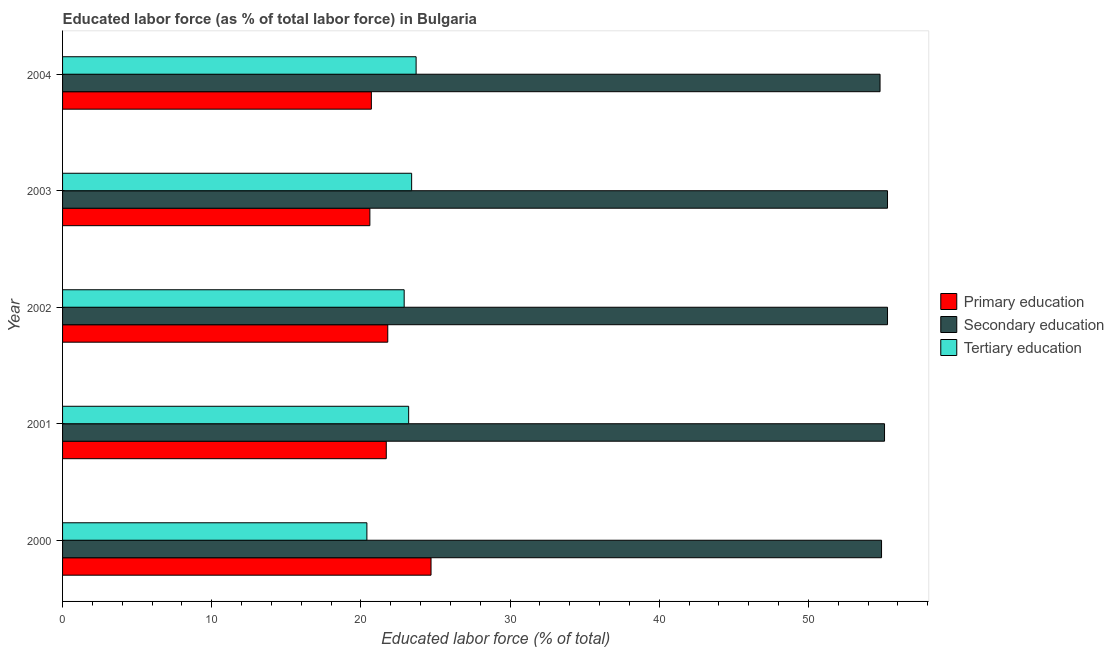Are the number of bars on each tick of the Y-axis equal?
Ensure brevity in your answer.  Yes. How many bars are there on the 5th tick from the bottom?
Provide a short and direct response. 3. What is the label of the 2nd group of bars from the top?
Keep it short and to the point. 2003. In how many cases, is the number of bars for a given year not equal to the number of legend labels?
Keep it short and to the point. 0. What is the percentage of labor force who received tertiary education in 2001?
Ensure brevity in your answer.  23.2. Across all years, what is the maximum percentage of labor force who received secondary education?
Offer a terse response. 55.3. Across all years, what is the minimum percentage of labor force who received tertiary education?
Provide a succinct answer. 20.4. In which year was the percentage of labor force who received primary education maximum?
Your answer should be very brief. 2000. In which year was the percentage of labor force who received secondary education minimum?
Offer a terse response. 2004. What is the total percentage of labor force who received secondary education in the graph?
Offer a very short reply. 275.4. What is the difference between the percentage of labor force who received tertiary education in 2002 and the percentage of labor force who received secondary education in 2000?
Provide a succinct answer. -32. What is the average percentage of labor force who received tertiary education per year?
Make the answer very short. 22.72. In the year 2002, what is the difference between the percentage of labor force who received secondary education and percentage of labor force who received tertiary education?
Offer a very short reply. 32.4. In how many years, is the percentage of labor force who received secondary education greater than 46 %?
Keep it short and to the point. 5. What is the difference between the highest and the second highest percentage of labor force who received secondary education?
Provide a short and direct response. 0. What is the difference between the highest and the lowest percentage of labor force who received secondary education?
Provide a succinct answer. 0.5. What does the 1st bar from the top in 2004 represents?
Give a very brief answer. Tertiary education. What does the 3rd bar from the bottom in 2003 represents?
Give a very brief answer. Tertiary education. Is it the case that in every year, the sum of the percentage of labor force who received primary education and percentage of labor force who received secondary education is greater than the percentage of labor force who received tertiary education?
Offer a very short reply. Yes. What is the difference between two consecutive major ticks on the X-axis?
Your answer should be compact. 10. Does the graph contain any zero values?
Give a very brief answer. No. Where does the legend appear in the graph?
Ensure brevity in your answer.  Center right. What is the title of the graph?
Give a very brief answer. Educated labor force (as % of total labor force) in Bulgaria. Does "Labor Tax" appear as one of the legend labels in the graph?
Provide a succinct answer. No. What is the label or title of the X-axis?
Your answer should be compact. Educated labor force (% of total). What is the label or title of the Y-axis?
Your answer should be very brief. Year. What is the Educated labor force (% of total) of Primary education in 2000?
Your answer should be compact. 24.7. What is the Educated labor force (% of total) of Secondary education in 2000?
Provide a succinct answer. 54.9. What is the Educated labor force (% of total) of Tertiary education in 2000?
Your answer should be very brief. 20.4. What is the Educated labor force (% of total) of Primary education in 2001?
Provide a succinct answer. 21.7. What is the Educated labor force (% of total) of Secondary education in 2001?
Give a very brief answer. 55.1. What is the Educated labor force (% of total) of Tertiary education in 2001?
Provide a succinct answer. 23.2. What is the Educated labor force (% of total) in Primary education in 2002?
Keep it short and to the point. 21.8. What is the Educated labor force (% of total) in Secondary education in 2002?
Give a very brief answer. 55.3. What is the Educated labor force (% of total) of Tertiary education in 2002?
Make the answer very short. 22.9. What is the Educated labor force (% of total) in Primary education in 2003?
Provide a succinct answer. 20.6. What is the Educated labor force (% of total) of Secondary education in 2003?
Your answer should be very brief. 55.3. What is the Educated labor force (% of total) in Tertiary education in 2003?
Ensure brevity in your answer.  23.4. What is the Educated labor force (% of total) of Primary education in 2004?
Your answer should be compact. 20.7. What is the Educated labor force (% of total) in Secondary education in 2004?
Your response must be concise. 54.8. What is the Educated labor force (% of total) in Tertiary education in 2004?
Make the answer very short. 23.7. Across all years, what is the maximum Educated labor force (% of total) in Primary education?
Your response must be concise. 24.7. Across all years, what is the maximum Educated labor force (% of total) in Secondary education?
Provide a succinct answer. 55.3. Across all years, what is the maximum Educated labor force (% of total) in Tertiary education?
Make the answer very short. 23.7. Across all years, what is the minimum Educated labor force (% of total) of Primary education?
Make the answer very short. 20.6. Across all years, what is the minimum Educated labor force (% of total) in Secondary education?
Offer a very short reply. 54.8. Across all years, what is the minimum Educated labor force (% of total) of Tertiary education?
Offer a very short reply. 20.4. What is the total Educated labor force (% of total) of Primary education in the graph?
Your response must be concise. 109.5. What is the total Educated labor force (% of total) of Secondary education in the graph?
Provide a short and direct response. 275.4. What is the total Educated labor force (% of total) of Tertiary education in the graph?
Provide a succinct answer. 113.6. What is the difference between the Educated labor force (% of total) of Primary education in 2000 and that in 2001?
Offer a terse response. 3. What is the difference between the Educated labor force (% of total) in Tertiary education in 2000 and that in 2001?
Provide a short and direct response. -2.8. What is the difference between the Educated labor force (% of total) of Primary education in 2000 and that in 2002?
Offer a terse response. 2.9. What is the difference between the Educated labor force (% of total) in Primary education in 2000 and that in 2003?
Your answer should be compact. 4.1. What is the difference between the Educated labor force (% of total) of Secondary education in 2000 and that in 2003?
Make the answer very short. -0.4. What is the difference between the Educated labor force (% of total) in Tertiary education in 2000 and that in 2004?
Provide a succinct answer. -3.3. What is the difference between the Educated labor force (% of total) of Tertiary education in 2001 and that in 2002?
Your response must be concise. 0.3. What is the difference between the Educated labor force (% of total) of Tertiary education in 2001 and that in 2003?
Your response must be concise. -0.2. What is the difference between the Educated labor force (% of total) of Primary education in 2001 and that in 2004?
Your response must be concise. 1. What is the difference between the Educated labor force (% of total) in Secondary education in 2001 and that in 2004?
Give a very brief answer. 0.3. What is the difference between the Educated labor force (% of total) in Tertiary education in 2001 and that in 2004?
Your answer should be very brief. -0.5. What is the difference between the Educated labor force (% of total) of Primary education in 2002 and that in 2003?
Offer a very short reply. 1.2. What is the difference between the Educated labor force (% of total) in Secondary education in 2002 and that in 2003?
Keep it short and to the point. 0. What is the difference between the Educated labor force (% of total) of Secondary education in 2002 and that in 2004?
Offer a terse response. 0.5. What is the difference between the Educated labor force (% of total) of Tertiary education in 2002 and that in 2004?
Your answer should be very brief. -0.8. What is the difference between the Educated labor force (% of total) of Secondary education in 2003 and that in 2004?
Your answer should be compact. 0.5. What is the difference between the Educated labor force (% of total) in Tertiary education in 2003 and that in 2004?
Offer a very short reply. -0.3. What is the difference between the Educated labor force (% of total) of Primary education in 2000 and the Educated labor force (% of total) of Secondary education in 2001?
Offer a very short reply. -30.4. What is the difference between the Educated labor force (% of total) of Primary education in 2000 and the Educated labor force (% of total) of Tertiary education in 2001?
Offer a terse response. 1.5. What is the difference between the Educated labor force (% of total) of Secondary education in 2000 and the Educated labor force (% of total) of Tertiary education in 2001?
Your answer should be compact. 31.7. What is the difference between the Educated labor force (% of total) in Primary education in 2000 and the Educated labor force (% of total) in Secondary education in 2002?
Provide a succinct answer. -30.6. What is the difference between the Educated labor force (% of total) in Primary education in 2000 and the Educated labor force (% of total) in Tertiary education in 2002?
Provide a succinct answer. 1.8. What is the difference between the Educated labor force (% of total) in Secondary education in 2000 and the Educated labor force (% of total) in Tertiary education in 2002?
Keep it short and to the point. 32. What is the difference between the Educated labor force (% of total) of Primary education in 2000 and the Educated labor force (% of total) of Secondary education in 2003?
Your answer should be very brief. -30.6. What is the difference between the Educated labor force (% of total) of Primary education in 2000 and the Educated labor force (% of total) of Tertiary education in 2003?
Provide a short and direct response. 1.3. What is the difference between the Educated labor force (% of total) in Secondary education in 2000 and the Educated labor force (% of total) in Tertiary education in 2003?
Your response must be concise. 31.5. What is the difference between the Educated labor force (% of total) of Primary education in 2000 and the Educated labor force (% of total) of Secondary education in 2004?
Ensure brevity in your answer.  -30.1. What is the difference between the Educated labor force (% of total) in Primary education in 2000 and the Educated labor force (% of total) in Tertiary education in 2004?
Offer a terse response. 1. What is the difference between the Educated labor force (% of total) of Secondary education in 2000 and the Educated labor force (% of total) of Tertiary education in 2004?
Make the answer very short. 31.2. What is the difference between the Educated labor force (% of total) in Primary education in 2001 and the Educated labor force (% of total) in Secondary education in 2002?
Your answer should be compact. -33.6. What is the difference between the Educated labor force (% of total) of Secondary education in 2001 and the Educated labor force (% of total) of Tertiary education in 2002?
Provide a succinct answer. 32.2. What is the difference between the Educated labor force (% of total) of Primary education in 2001 and the Educated labor force (% of total) of Secondary education in 2003?
Ensure brevity in your answer.  -33.6. What is the difference between the Educated labor force (% of total) in Secondary education in 2001 and the Educated labor force (% of total) in Tertiary education in 2003?
Give a very brief answer. 31.7. What is the difference between the Educated labor force (% of total) of Primary education in 2001 and the Educated labor force (% of total) of Secondary education in 2004?
Make the answer very short. -33.1. What is the difference between the Educated labor force (% of total) in Secondary education in 2001 and the Educated labor force (% of total) in Tertiary education in 2004?
Your answer should be very brief. 31.4. What is the difference between the Educated labor force (% of total) of Primary education in 2002 and the Educated labor force (% of total) of Secondary education in 2003?
Your answer should be compact. -33.5. What is the difference between the Educated labor force (% of total) of Primary education in 2002 and the Educated labor force (% of total) of Tertiary education in 2003?
Your response must be concise. -1.6. What is the difference between the Educated labor force (% of total) of Secondary education in 2002 and the Educated labor force (% of total) of Tertiary education in 2003?
Give a very brief answer. 31.9. What is the difference between the Educated labor force (% of total) of Primary education in 2002 and the Educated labor force (% of total) of Secondary education in 2004?
Offer a very short reply. -33. What is the difference between the Educated labor force (% of total) of Primary education in 2002 and the Educated labor force (% of total) of Tertiary education in 2004?
Provide a short and direct response. -1.9. What is the difference between the Educated labor force (% of total) in Secondary education in 2002 and the Educated labor force (% of total) in Tertiary education in 2004?
Provide a short and direct response. 31.6. What is the difference between the Educated labor force (% of total) of Primary education in 2003 and the Educated labor force (% of total) of Secondary education in 2004?
Provide a short and direct response. -34.2. What is the difference between the Educated labor force (% of total) of Secondary education in 2003 and the Educated labor force (% of total) of Tertiary education in 2004?
Give a very brief answer. 31.6. What is the average Educated labor force (% of total) of Primary education per year?
Your answer should be compact. 21.9. What is the average Educated labor force (% of total) of Secondary education per year?
Offer a terse response. 55.08. What is the average Educated labor force (% of total) of Tertiary education per year?
Offer a very short reply. 22.72. In the year 2000, what is the difference between the Educated labor force (% of total) in Primary education and Educated labor force (% of total) in Secondary education?
Offer a very short reply. -30.2. In the year 2000, what is the difference between the Educated labor force (% of total) in Secondary education and Educated labor force (% of total) in Tertiary education?
Your answer should be compact. 34.5. In the year 2001, what is the difference between the Educated labor force (% of total) of Primary education and Educated labor force (% of total) of Secondary education?
Your answer should be very brief. -33.4. In the year 2001, what is the difference between the Educated labor force (% of total) of Secondary education and Educated labor force (% of total) of Tertiary education?
Give a very brief answer. 31.9. In the year 2002, what is the difference between the Educated labor force (% of total) of Primary education and Educated labor force (% of total) of Secondary education?
Your response must be concise. -33.5. In the year 2002, what is the difference between the Educated labor force (% of total) in Primary education and Educated labor force (% of total) in Tertiary education?
Your answer should be compact. -1.1. In the year 2002, what is the difference between the Educated labor force (% of total) in Secondary education and Educated labor force (% of total) in Tertiary education?
Your answer should be compact. 32.4. In the year 2003, what is the difference between the Educated labor force (% of total) in Primary education and Educated labor force (% of total) in Secondary education?
Provide a succinct answer. -34.7. In the year 2003, what is the difference between the Educated labor force (% of total) in Secondary education and Educated labor force (% of total) in Tertiary education?
Provide a succinct answer. 31.9. In the year 2004, what is the difference between the Educated labor force (% of total) of Primary education and Educated labor force (% of total) of Secondary education?
Offer a very short reply. -34.1. In the year 2004, what is the difference between the Educated labor force (% of total) of Secondary education and Educated labor force (% of total) of Tertiary education?
Offer a terse response. 31.1. What is the ratio of the Educated labor force (% of total) in Primary education in 2000 to that in 2001?
Keep it short and to the point. 1.14. What is the ratio of the Educated labor force (% of total) of Secondary education in 2000 to that in 2001?
Provide a short and direct response. 1. What is the ratio of the Educated labor force (% of total) in Tertiary education in 2000 to that in 2001?
Offer a very short reply. 0.88. What is the ratio of the Educated labor force (% of total) of Primary education in 2000 to that in 2002?
Provide a succinct answer. 1.13. What is the ratio of the Educated labor force (% of total) in Tertiary education in 2000 to that in 2002?
Offer a terse response. 0.89. What is the ratio of the Educated labor force (% of total) in Primary education in 2000 to that in 2003?
Your response must be concise. 1.2. What is the ratio of the Educated labor force (% of total) in Secondary education in 2000 to that in 2003?
Provide a succinct answer. 0.99. What is the ratio of the Educated labor force (% of total) of Tertiary education in 2000 to that in 2003?
Give a very brief answer. 0.87. What is the ratio of the Educated labor force (% of total) of Primary education in 2000 to that in 2004?
Your answer should be compact. 1.19. What is the ratio of the Educated labor force (% of total) of Tertiary education in 2000 to that in 2004?
Offer a terse response. 0.86. What is the ratio of the Educated labor force (% of total) of Primary education in 2001 to that in 2002?
Offer a terse response. 1. What is the ratio of the Educated labor force (% of total) in Tertiary education in 2001 to that in 2002?
Give a very brief answer. 1.01. What is the ratio of the Educated labor force (% of total) in Primary education in 2001 to that in 2003?
Offer a very short reply. 1.05. What is the ratio of the Educated labor force (% of total) of Secondary education in 2001 to that in 2003?
Provide a succinct answer. 1. What is the ratio of the Educated labor force (% of total) in Tertiary education in 2001 to that in 2003?
Your answer should be compact. 0.99. What is the ratio of the Educated labor force (% of total) of Primary education in 2001 to that in 2004?
Provide a succinct answer. 1.05. What is the ratio of the Educated labor force (% of total) of Secondary education in 2001 to that in 2004?
Offer a very short reply. 1.01. What is the ratio of the Educated labor force (% of total) in Tertiary education in 2001 to that in 2004?
Give a very brief answer. 0.98. What is the ratio of the Educated labor force (% of total) in Primary education in 2002 to that in 2003?
Your answer should be very brief. 1.06. What is the ratio of the Educated labor force (% of total) of Tertiary education in 2002 to that in 2003?
Your answer should be compact. 0.98. What is the ratio of the Educated labor force (% of total) in Primary education in 2002 to that in 2004?
Provide a short and direct response. 1.05. What is the ratio of the Educated labor force (% of total) in Secondary education in 2002 to that in 2004?
Give a very brief answer. 1.01. What is the ratio of the Educated labor force (% of total) in Tertiary education in 2002 to that in 2004?
Your answer should be compact. 0.97. What is the ratio of the Educated labor force (% of total) of Secondary education in 2003 to that in 2004?
Make the answer very short. 1.01. What is the ratio of the Educated labor force (% of total) of Tertiary education in 2003 to that in 2004?
Your response must be concise. 0.99. What is the difference between the highest and the second highest Educated labor force (% of total) of Primary education?
Your answer should be compact. 2.9. What is the difference between the highest and the second highest Educated labor force (% of total) of Tertiary education?
Provide a succinct answer. 0.3. 